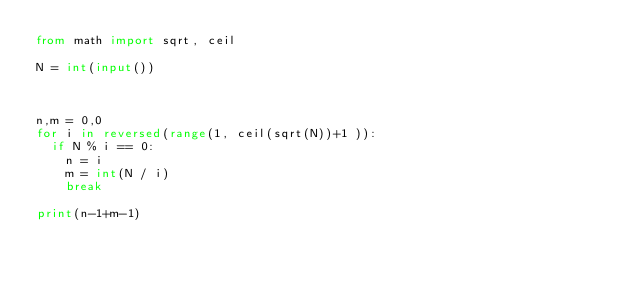Convert code to text. <code><loc_0><loc_0><loc_500><loc_500><_Python_>from math import sqrt, ceil

N = int(input())



n,m = 0,0
for i in reversed(range(1, ceil(sqrt(N))+1 )):
  if N % i == 0:
    n = i
    m = int(N / i)
    break

print(n-1+m-1)</code> 